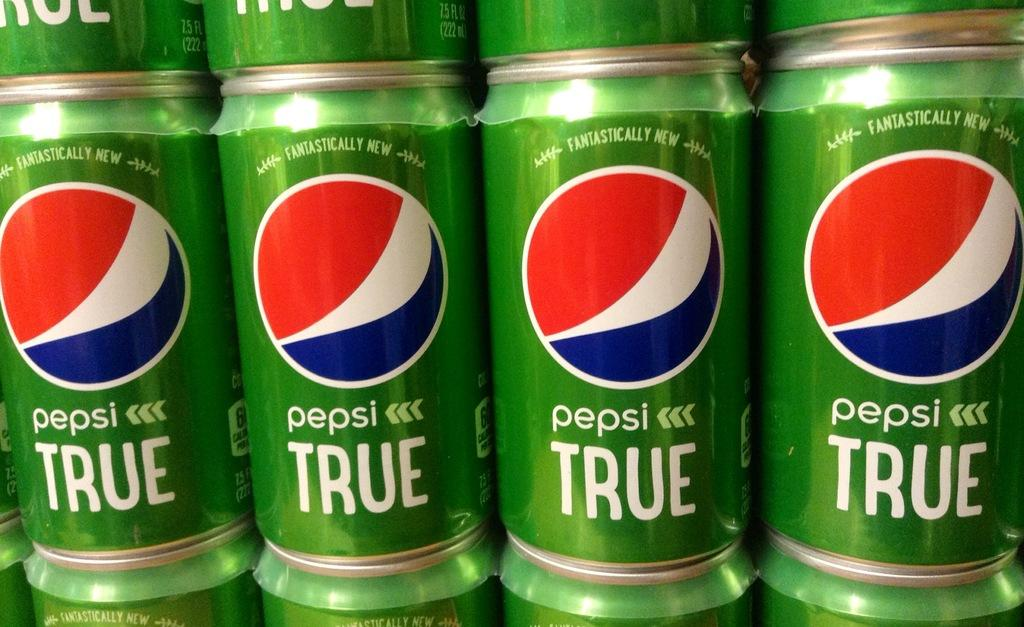<image>
Offer a succinct explanation of the picture presented. Multiple green cans of Pepsi True are stacked on top of each other. 